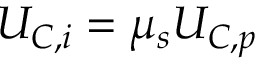<formula> <loc_0><loc_0><loc_500><loc_500>U _ { C , i } = \mu _ { s } U _ { C , p }</formula> 